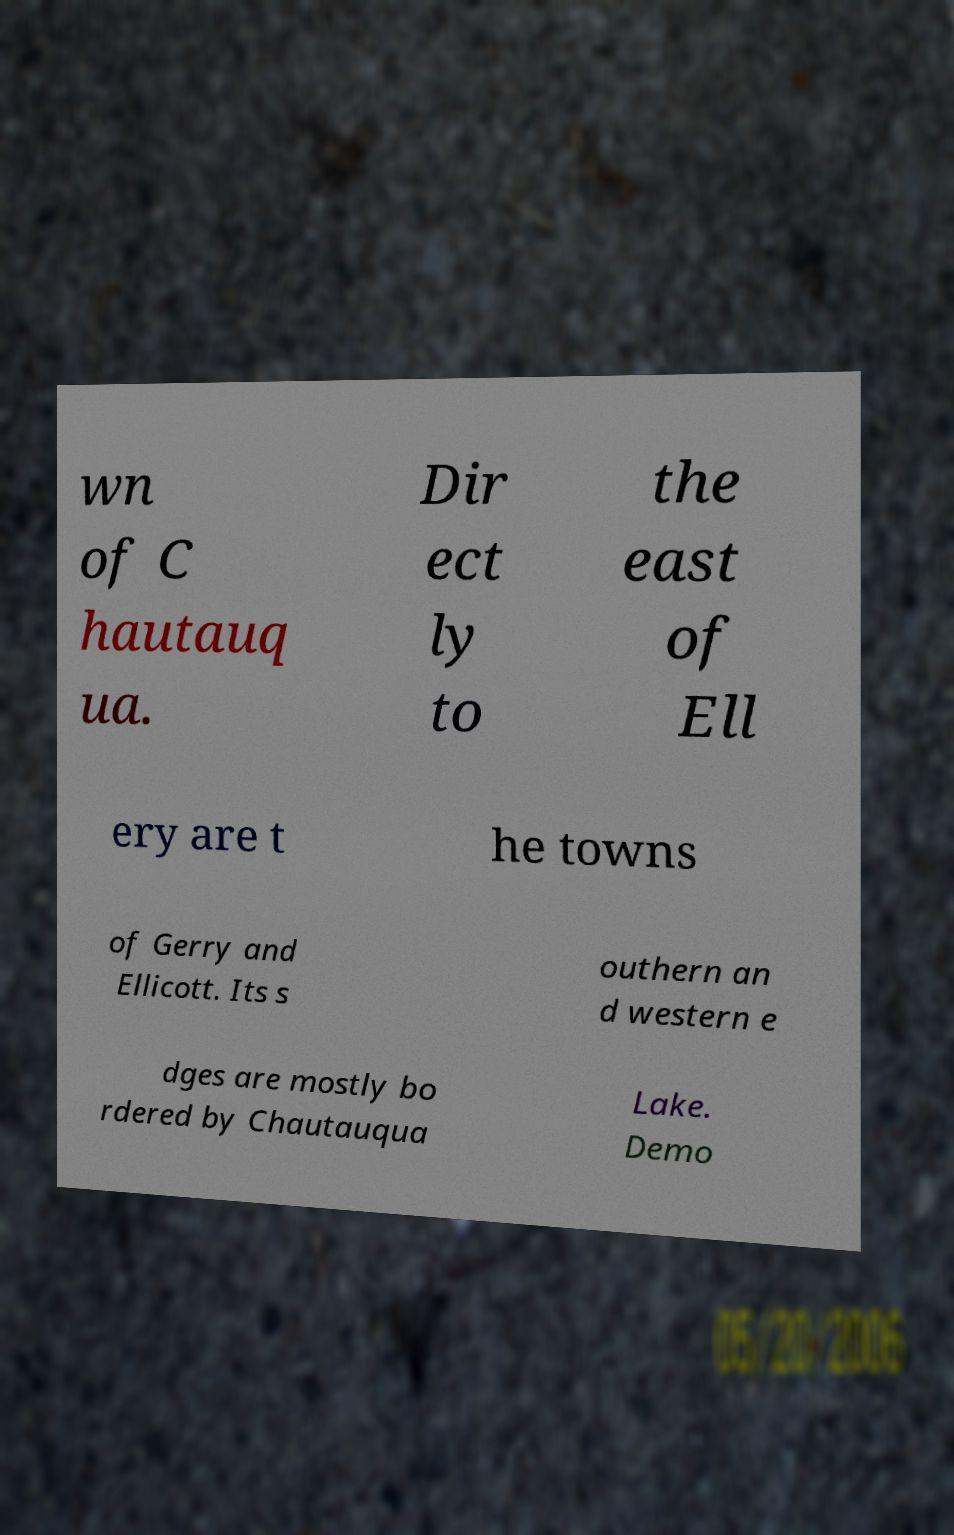Can you read and provide the text displayed in the image?This photo seems to have some interesting text. Can you extract and type it out for me? wn of C hautauq ua. Dir ect ly to the east of Ell ery are t he towns of Gerry and Ellicott. Its s outhern an d western e dges are mostly bo rdered by Chautauqua Lake. Demo 